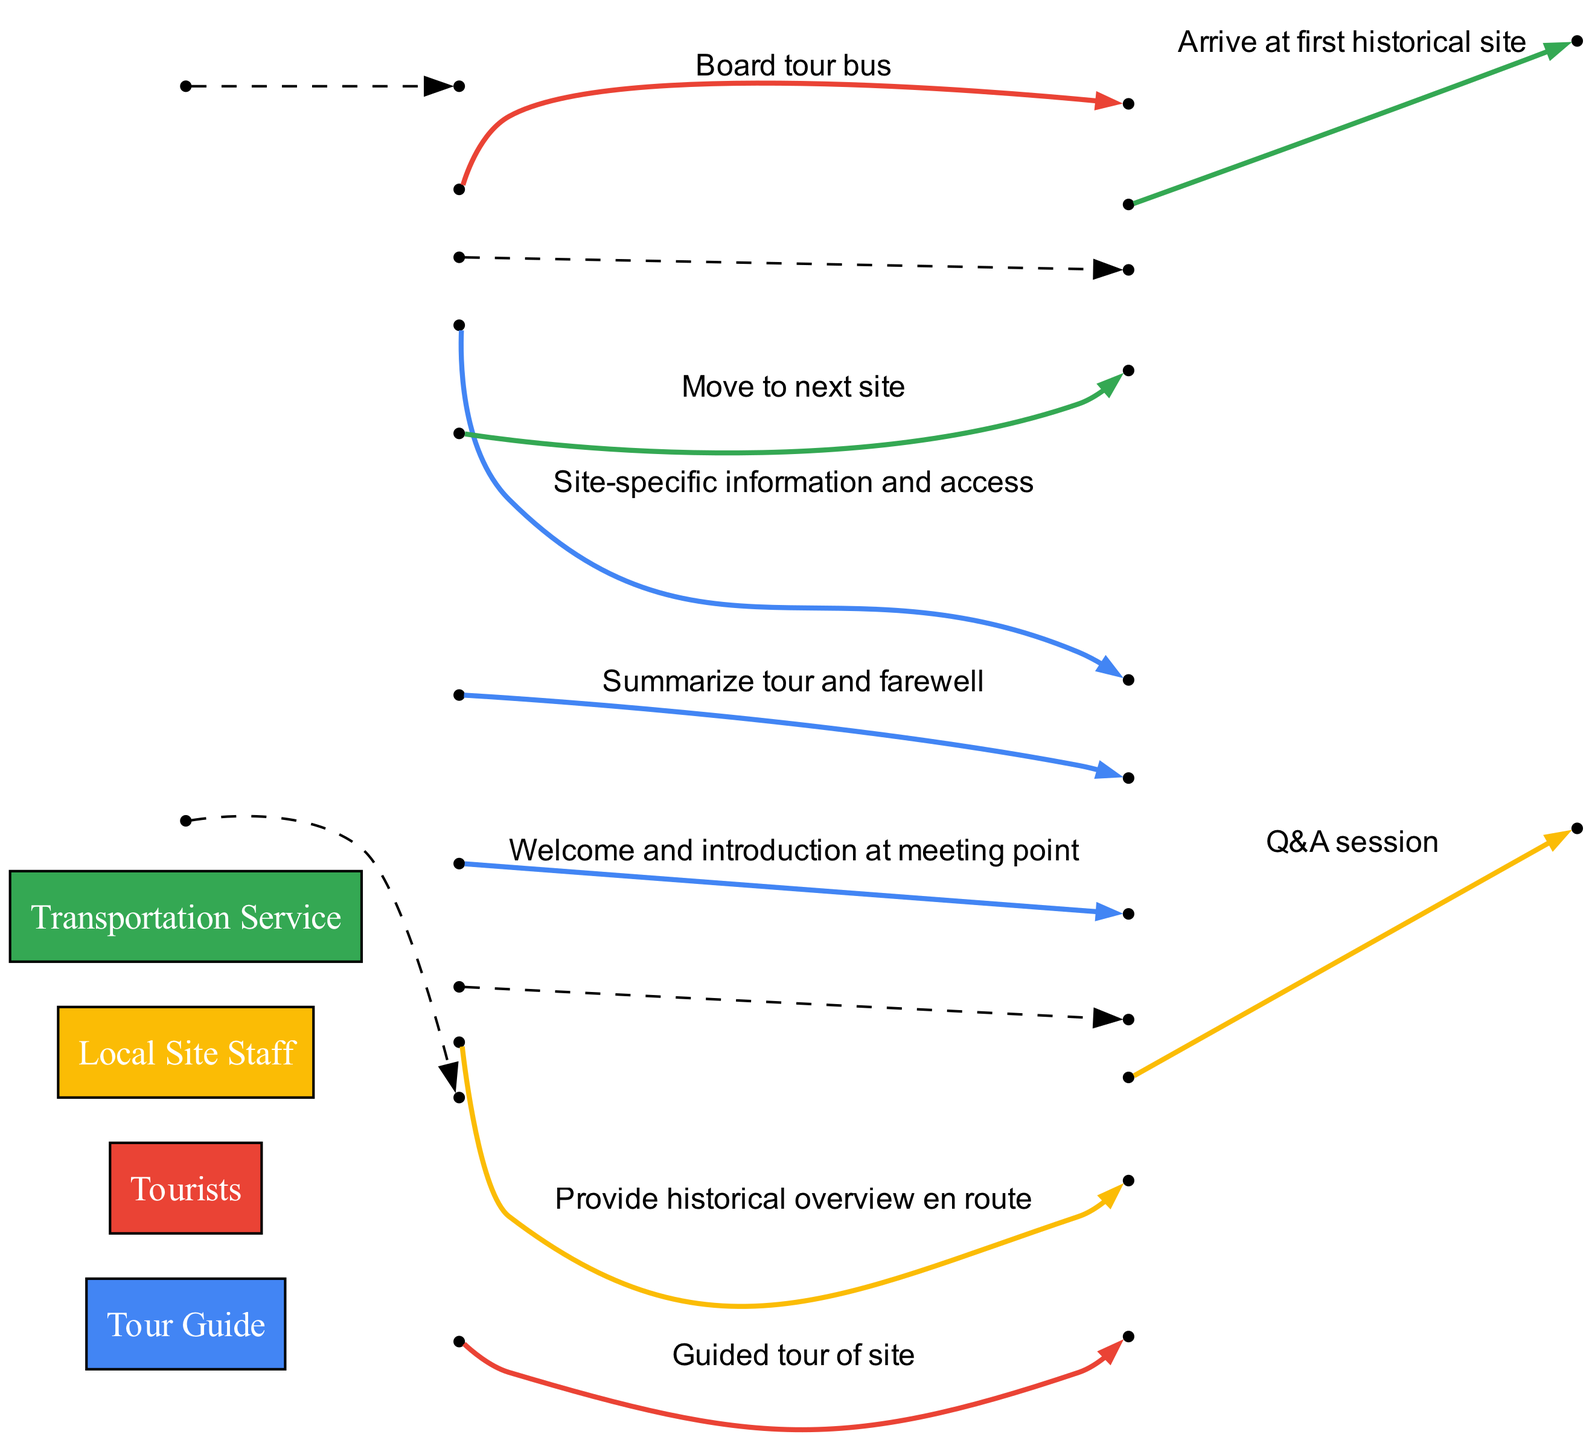What is the first message exchanged in the sequence? The first message is exchanged from the Tour Guide to the Tourists, which states, "Welcome and introduction at meeting point." This is the first event listed in the sequence.
Answer: Welcome and introduction at meeting point How many actors are involved in the tour process? There are four distinct actors listed: Tour Guide, Tourists, Local Site Staff, and Transportation Service. This is found in the initial list of actors.
Answer: 4 Who provides the historical overview en route? The Tour Guide provides the historical overview en route, as stated in the third event of the sequence.
Answer: Tour Guide What message is exchanged between Tourists and Tour Guide during the tour? The message exchanged is a "Q&A session," which is the seventh event in the sequence. This indicates interaction between the tourists and the guide.
Answer: Q&A session What happens after the Transportation Service arrives at the first historical site? After arriving, the Local Site Staff provides "Site-specific information and access" to the tourists. This follows the fourth event in the sequence.
Answer: Site-specific information and access Which actor concludes the tour with a summary? The Tour Guide concludes the tour by summarizing and offering a farewell, as stated in the last event of the sequence.
Answer: Tour Guide How many messages are exchanged in total during the tour? There are seven distinct messages exchanged between the actors, as indicated by the number of events listed—each event corresponds to a message.
Answer: 7 What is the purpose of the Transportation Service in the sequence? The Transportation Service is involved in moving the group between locations, as evidenced by the interactions where the Tour Guide instructs the service to "Board tour bus" and to "Move to next site."
Answer: Move between locations Which actor is responsible for providing access to each site? The Local Site Staff is responsible for providing access to each site, which is clear from the message exchanged after the Transportation Service arrives at the site.
Answer: Local Site Staff 